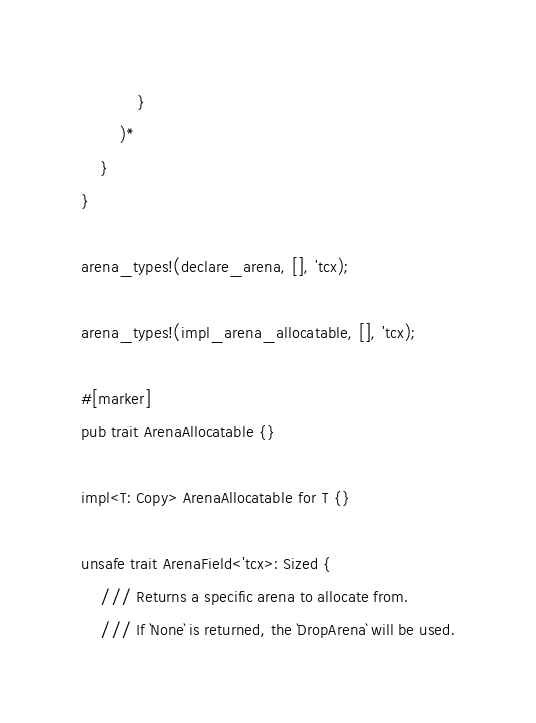Convert code to text. <code><loc_0><loc_0><loc_500><loc_500><_Rust_>            }
        )*
    }
}

arena_types!(declare_arena, [], 'tcx);

arena_types!(impl_arena_allocatable, [], 'tcx);

#[marker]
pub trait ArenaAllocatable {}

impl<T: Copy> ArenaAllocatable for T {}

unsafe trait ArenaField<'tcx>: Sized {
    /// Returns a specific arena to allocate from.
    /// If `None` is returned, the `DropArena` will be used.</code> 